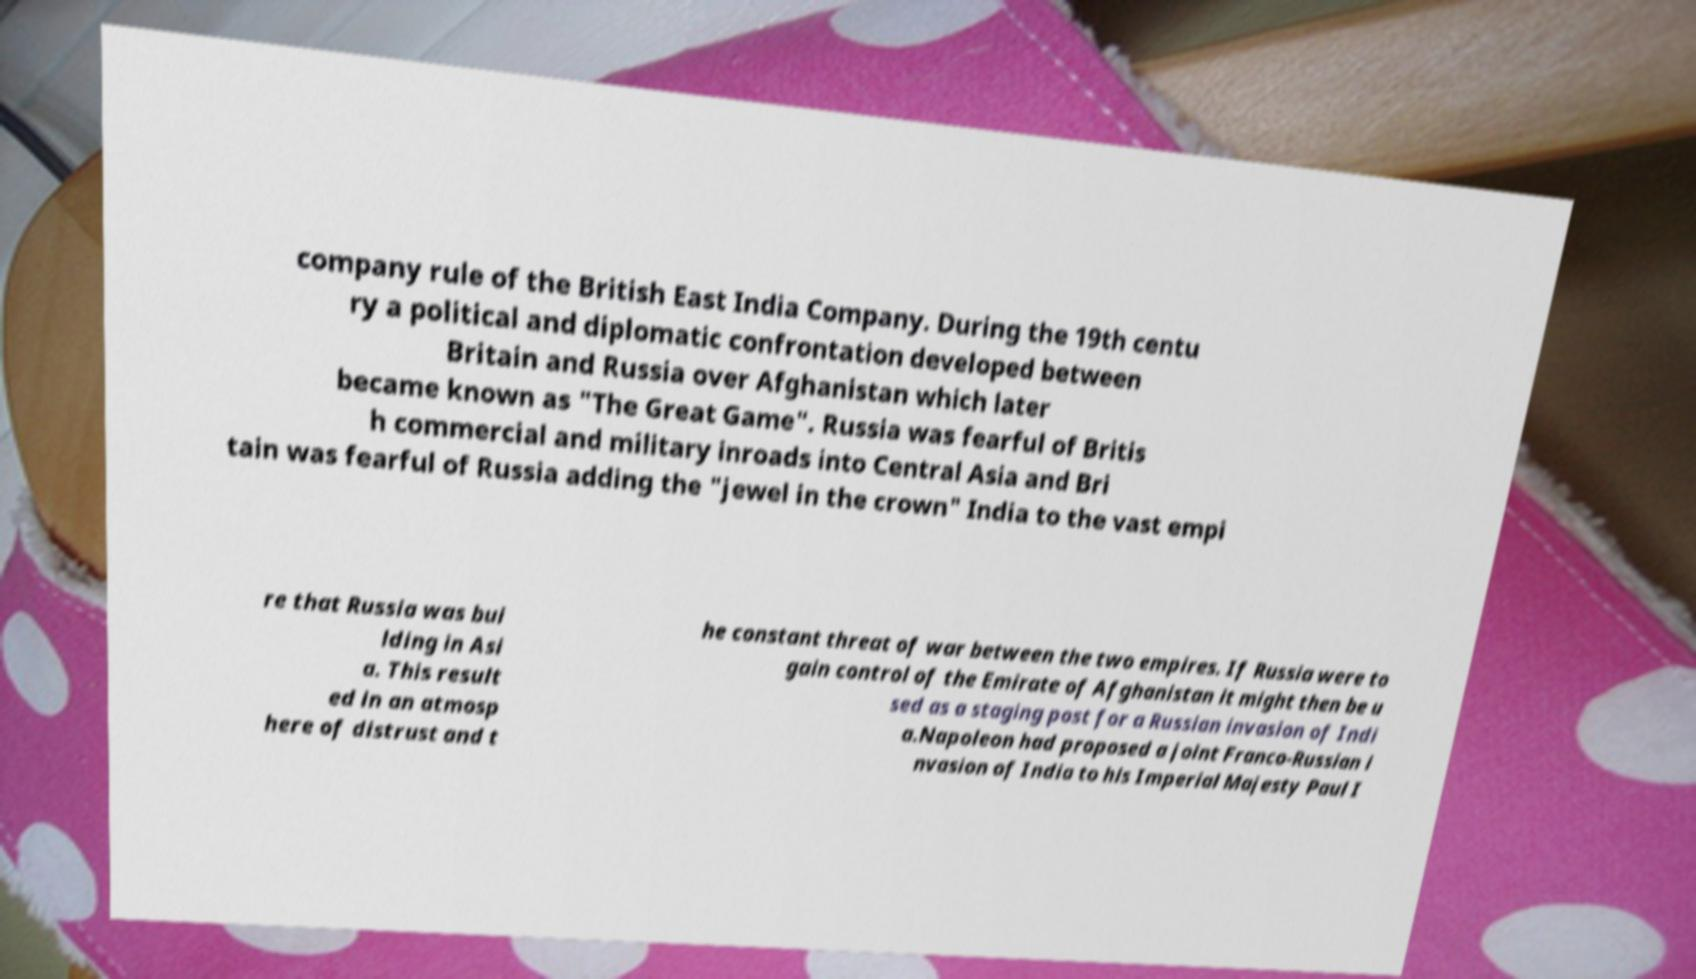Can you accurately transcribe the text from the provided image for me? company rule of the British East India Company. During the 19th centu ry a political and diplomatic confrontation developed between Britain and Russia over Afghanistan which later became known as "The Great Game". Russia was fearful of Britis h commercial and military inroads into Central Asia and Bri tain was fearful of Russia adding the "jewel in the crown" India to the vast empi re that Russia was bui lding in Asi a. This result ed in an atmosp here of distrust and t he constant threat of war between the two empires. If Russia were to gain control of the Emirate of Afghanistan it might then be u sed as a staging post for a Russian invasion of Indi a.Napoleon had proposed a joint Franco-Russian i nvasion of India to his Imperial Majesty Paul I 